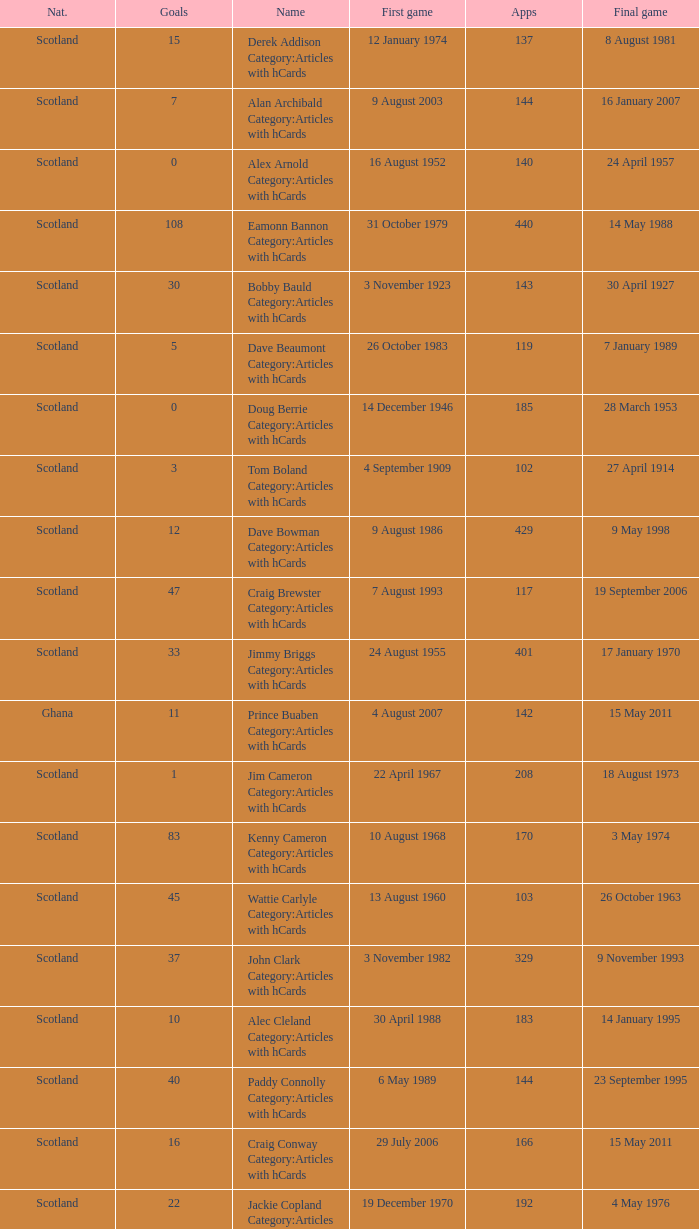What name has 118 as the apps? Ron Yeats Category:Articles with hCards. 